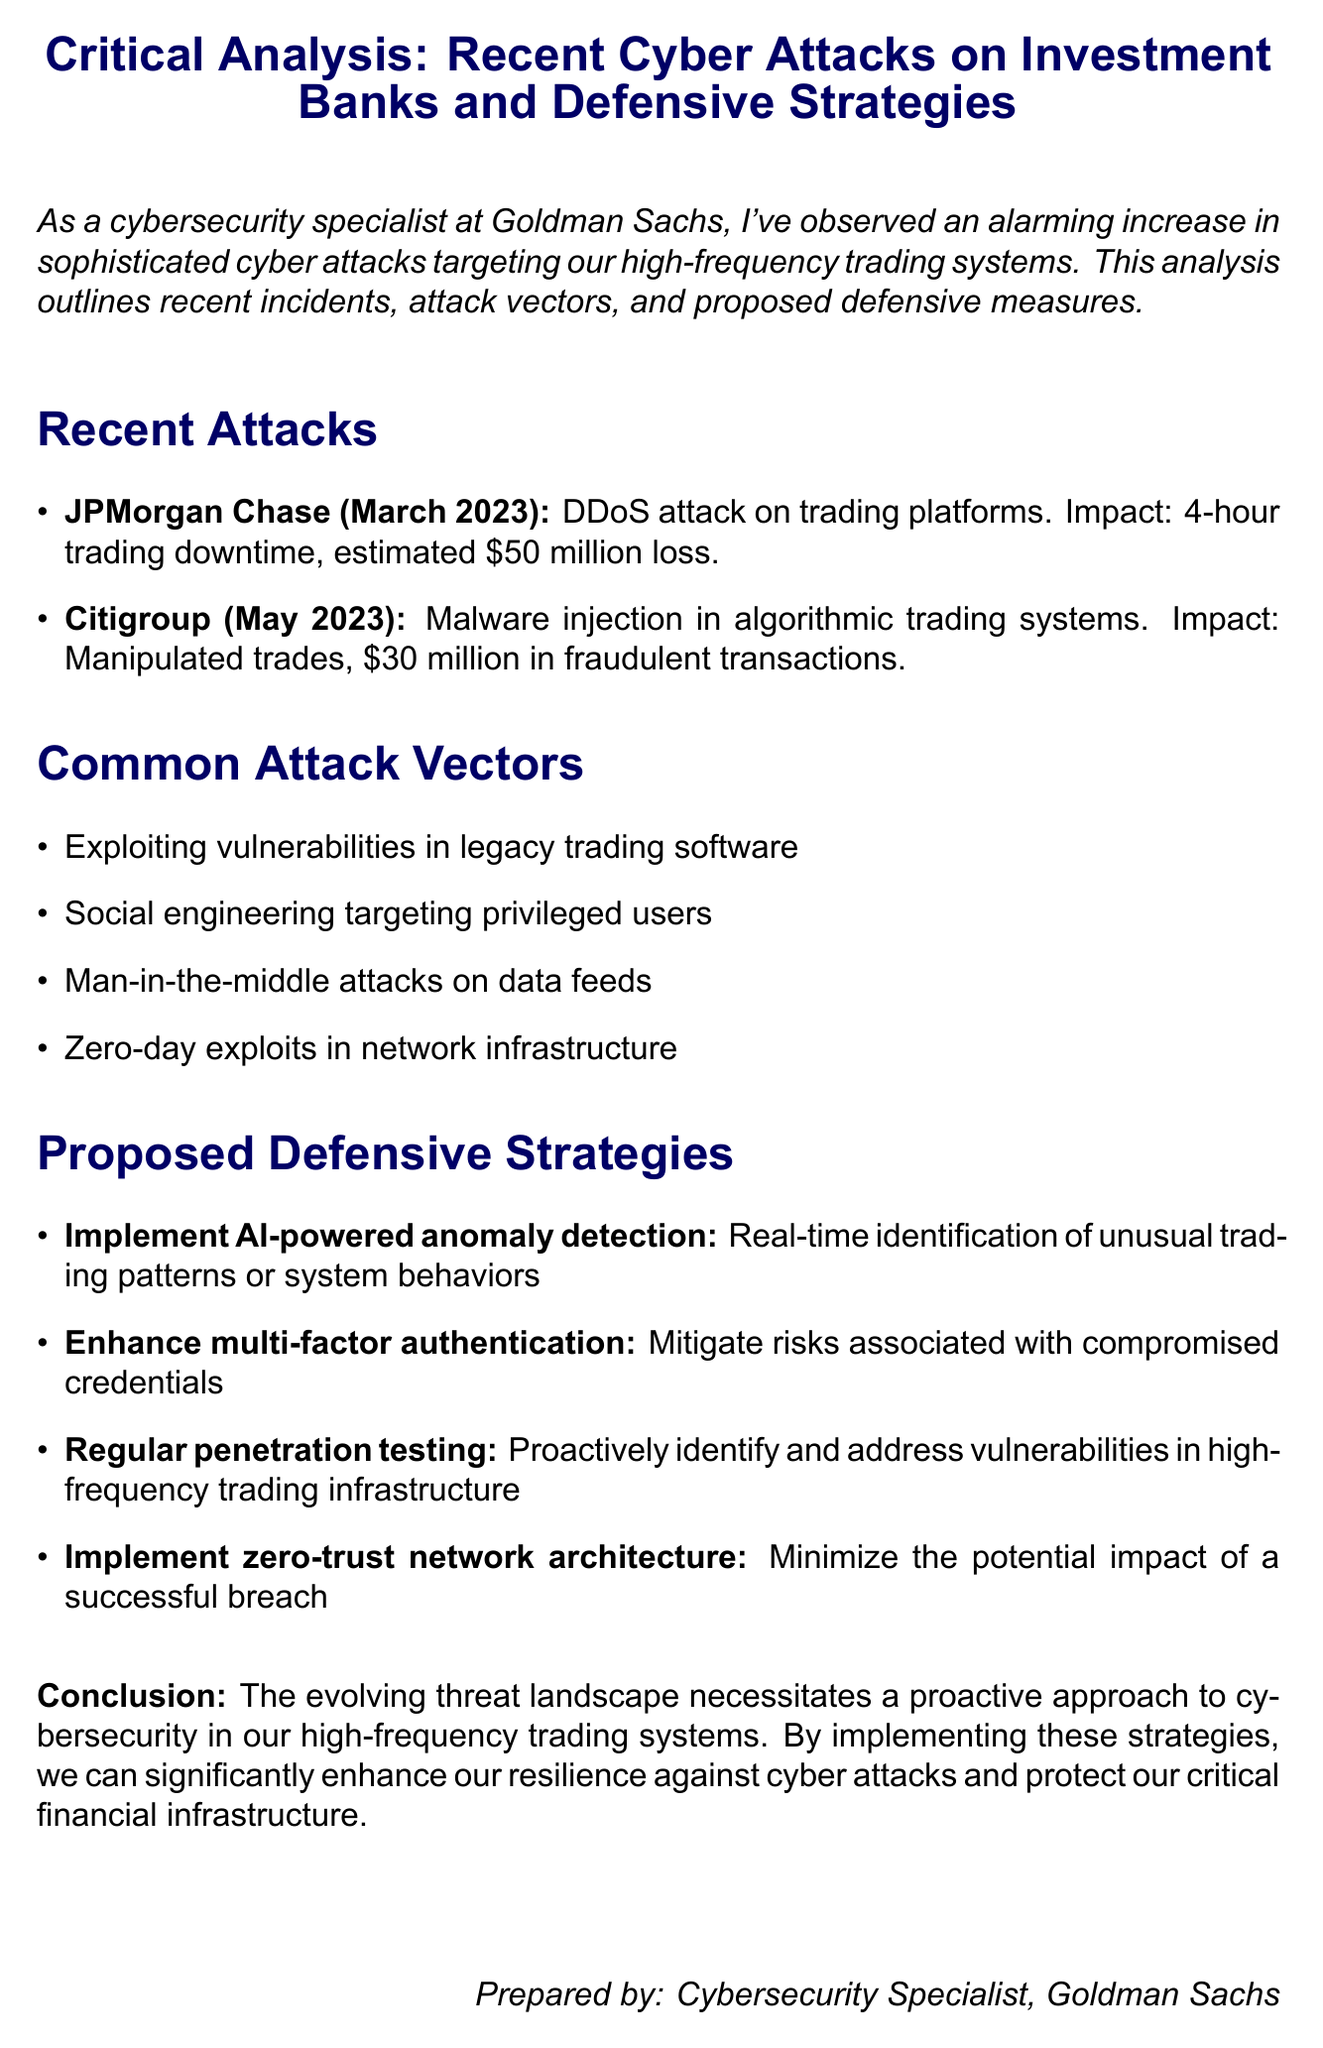What was the date of the attack on JPMorgan Chase? The document states that the attack on JPMorgan Chase occurred in March 2023.
Answer: March 2023 What type of attack did Citigroup experience? The document specifies that Citigroup faced a malware injection in their algorithmic trading systems.
Answer: Malware injection What was the estimated loss for JPMorgan Chase due to the attack? According to the document, the estimated loss for JPMorgan Chase was $50 million.
Answer: $50 million List one common attack vector mentioned in the analysis. The document lists multiple attack vectors, one of which is "Exploiting vulnerabilities in legacy trading software."
Answer: Exploiting vulnerabilities in legacy trading software What is one proposed defensive strategy outlined in the document? The document mentions several strategies, including "Implement AI-powered anomaly detection."
Answer: Implement AI-powered anomaly detection What was the impact of the malware injection on Citigroup? The document indicates that the malware injection led to manipulated trades and $30 million in fraudulent transactions.
Answer: $30 million in fraudulent transactions What benefit does enhancing multi-factor authentication provide? The document states that enhancing multi-factor authentication mitigates risks associated with compromised credentials.
Answer: Mitigate risks associated with compromised credentials Which financial institution experienced a DDoS attack? The document identifies JPMorgan Chase as the institution that faced a DDoS attack.
Answer: JPMorgan Chase What is the conclusion drawn in the document regarding the evolving threat landscape? The conclusion emphasizes that a proactive approach to cybersecurity is necessary in high-frequency trading systems.
Answer: A proactive approach to cybersecurity 